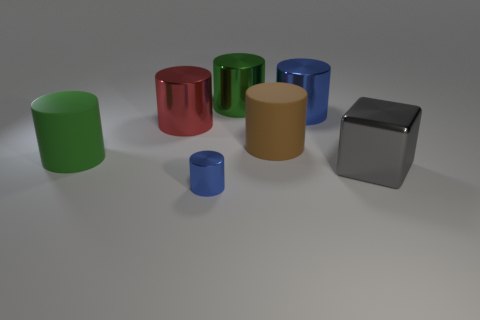Subtract all blue balls. How many blue cylinders are left? 2 Subtract all brown cylinders. How many cylinders are left? 5 Subtract 1 cylinders. How many cylinders are left? 5 Subtract all large blue metal cylinders. How many cylinders are left? 5 Subtract all purple cylinders. Subtract all gray cubes. How many cylinders are left? 6 Add 1 big green cylinders. How many objects exist? 8 Add 5 rubber objects. How many rubber objects are left? 7 Add 5 large blue spheres. How many large blue spheres exist? 5 Subtract 0 purple spheres. How many objects are left? 7 Subtract all blocks. How many objects are left? 6 